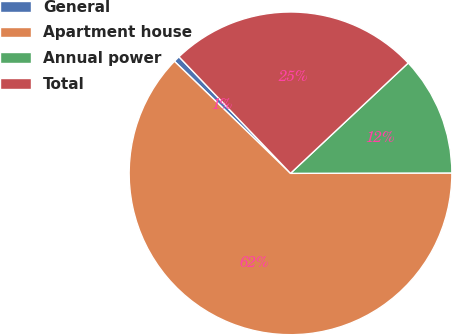Convert chart. <chart><loc_0><loc_0><loc_500><loc_500><pie_chart><fcel>General<fcel>Apartment house<fcel>Annual power<fcel>Total<nl><fcel>0.63%<fcel>62.26%<fcel>11.95%<fcel>25.16%<nl></chart> 